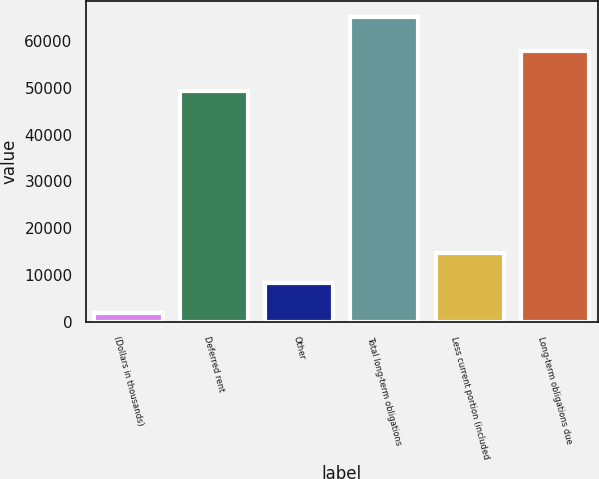Convert chart to OTSL. <chart><loc_0><loc_0><loc_500><loc_500><bar_chart><fcel>(Dollars in thousands)<fcel>Deferred rent<fcel>Other<fcel>Total long-term obligations<fcel>Less current portion (included<fcel>Long-term obligations due<nl><fcel>2007<fcel>49205<fcel>8320.3<fcel>65140<fcel>14633.6<fcel>57756<nl></chart> 